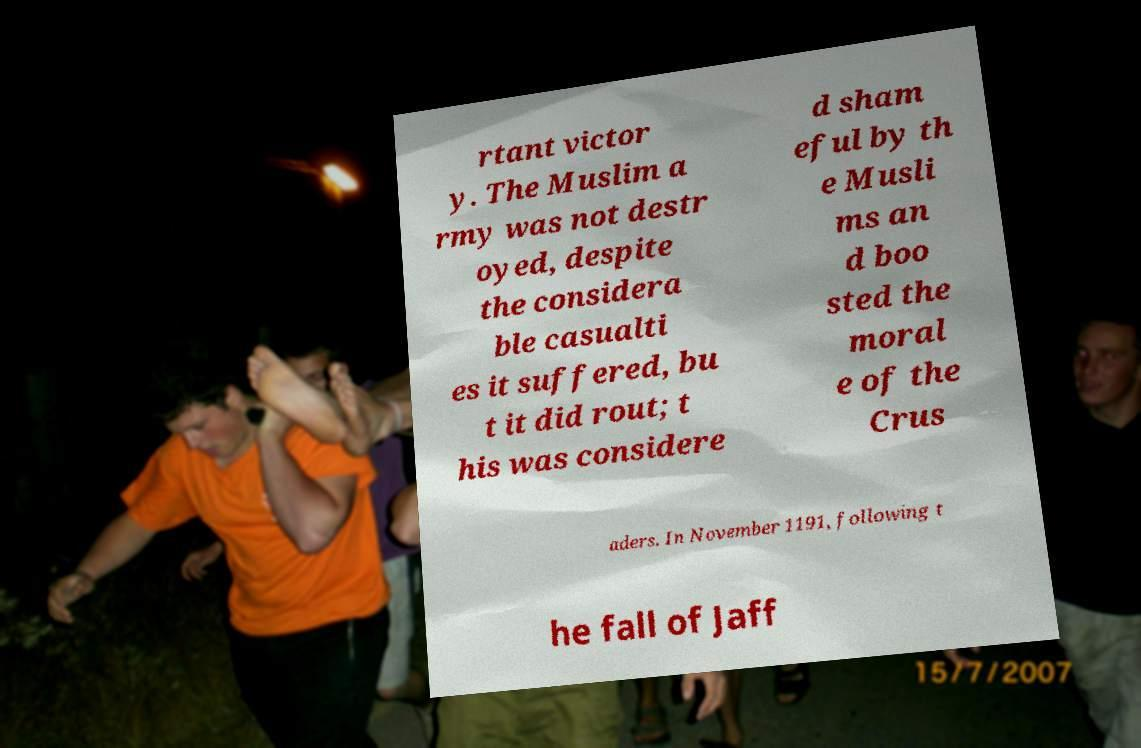Can you accurately transcribe the text from the provided image for me? rtant victor y. The Muslim a rmy was not destr oyed, despite the considera ble casualti es it suffered, bu t it did rout; t his was considere d sham eful by th e Musli ms an d boo sted the moral e of the Crus aders. In November 1191, following t he fall of Jaff 